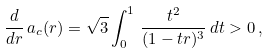Convert formula to latex. <formula><loc_0><loc_0><loc_500><loc_500>\frac { d } { d r } \, a _ { c } ( r ) = \sqrt { 3 } \int _ { 0 } ^ { 1 } \, \frac { t ^ { 2 } } { ( 1 - t r ) ^ { 3 } } \, d t > 0 \, ,</formula> 